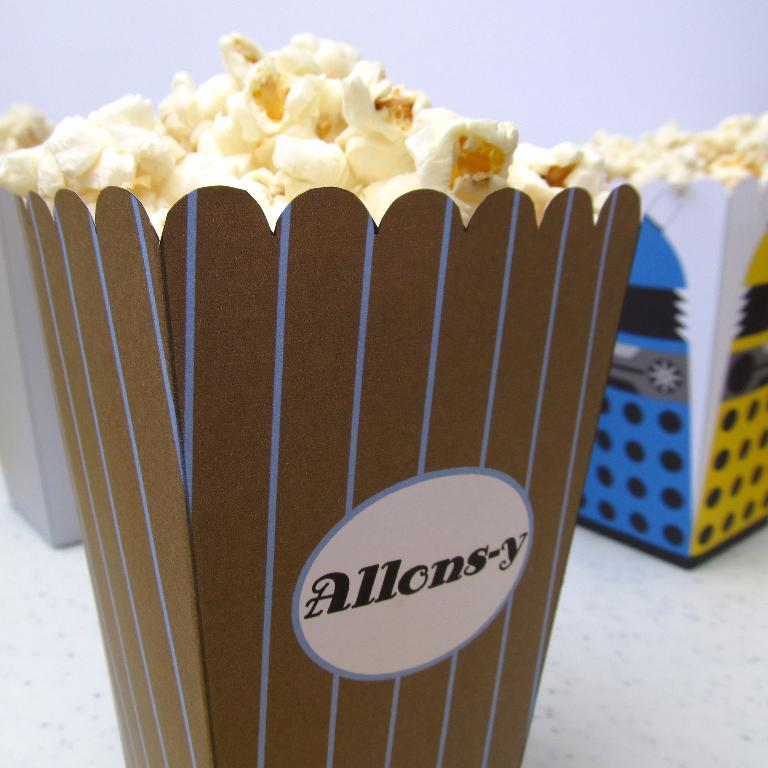What objects are present in the image? There are containers in the image. What is inside the containers? The containers contain popcorn. Where are the containers placed? The containers are placed on a surface. How many feet are visible in the image? There are no feet visible in the image. What type of mask is being worn by the person in the image? There is no person or mask present in the image. 